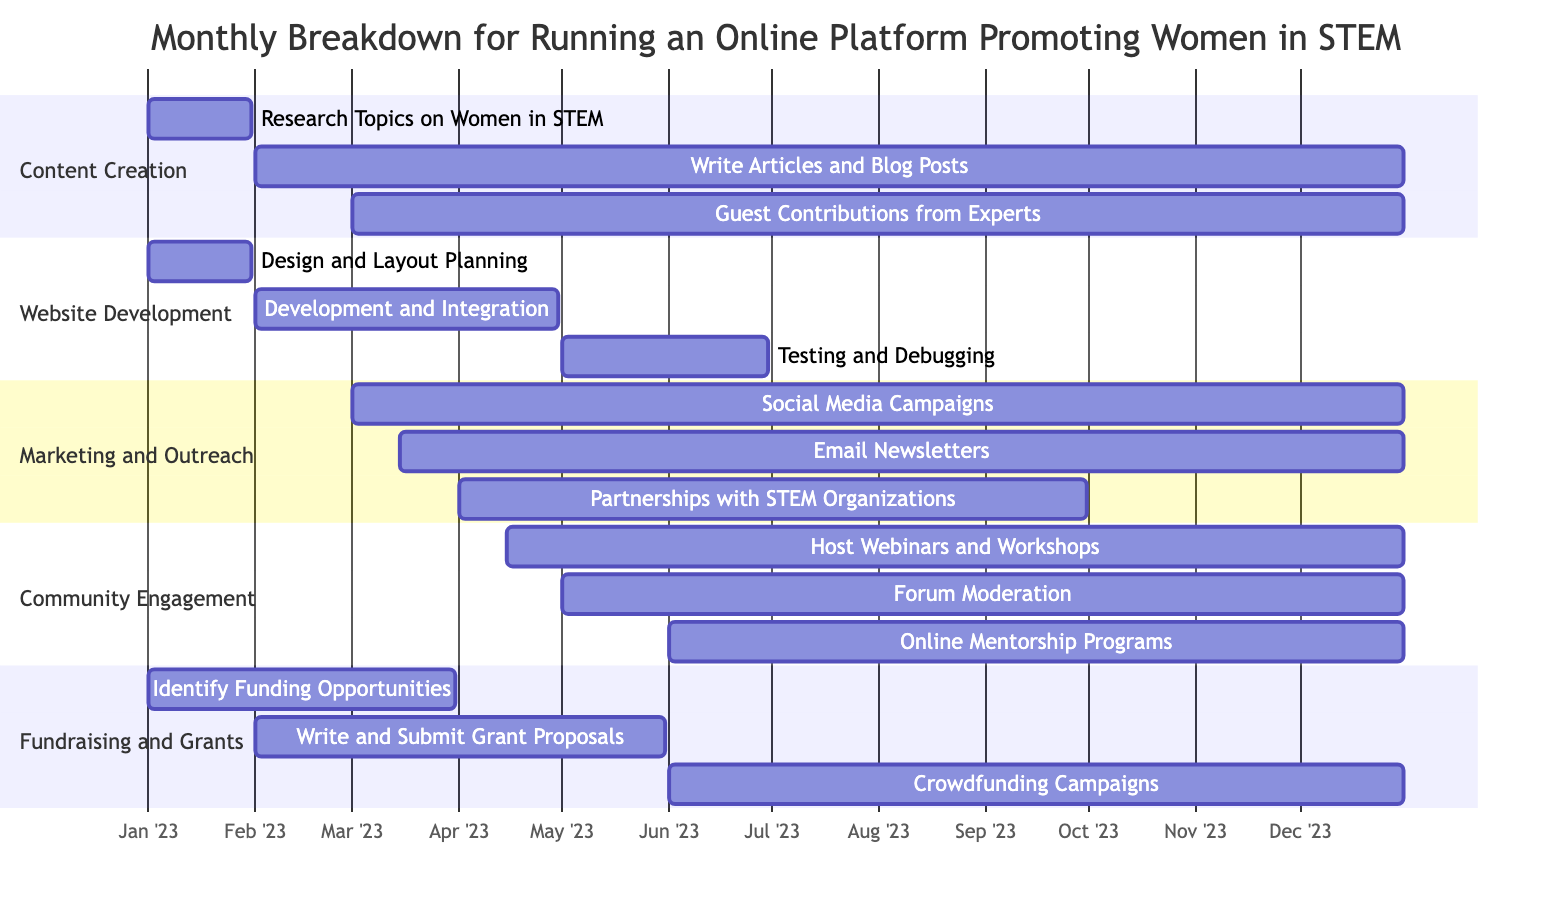What is the total number of main tasks in the Gantt Chart? There are five main tasks listed in the Gantt Chart: Content Creation, Website Development, Marketing and Outreach, Community Engagement, and Fundraising and Grants.
Answer: 5 Which subtask has the latest end date? The subtask "Write Articles and Blog Posts" ends on December 31, 2023, making it the latest subtask in terms of end date when compared to other subtasks.
Answer: Write Articles and Blog Posts How long is the Website Development phase? The Website Development phase starts on January 1, 2023, and ends on June 30, 2023. That is a total span of six months.
Answer: 6 months In which month do "Crowdfunding Campaigns" begin? The "Crowdfunding Campaigns" subtask starts on June 1, 2023. Therefore, they begin in June.
Answer: June What task starts on March 1, 2023? The task "Social Media Campaigns" starts on March 1, 2023, as shown by its start date in the Gantt Chart.
Answer: Social Media Campaigns Which two tasks overlap in their execution time during April? "Partnerships with STEM Organizations" and "Host Webinars and Workshops" both begin in April and have overlapping execution periods, as evidenced by their start and end dates.
Answer: Partnerships with STEM Organizations and Host Webinars and Workshops How many days is the "Testing and Debugging" phase? The "Testing and Debugging" phase begins on May 1, 2023, and ends on June 30, 2023, which is a duration of 61 days (May has 31 days and June has 30 days).
Answer: 61 days Name the first subtask that starts in 2023. The first subtask that starts is "Research Topics on Women in STEM," which begins on January 1, 2023.
Answer: Research Topics on Women in STEM What percentage of the year does the "Guest Contributions from Experts" subtask cover? The "Guest Contributions from Experts" start on March 1, 2023, and last until December 31, covering 10 months of the year, which is approximately 83% of the year.
Answer: 83% 